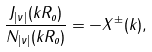Convert formula to latex. <formula><loc_0><loc_0><loc_500><loc_500>\frac { J _ { | \nu | } ( k R _ { o } ) } { N _ { | \nu | } ( k R _ { o } ) } = - X ^ { \pm } ( k ) ,</formula> 